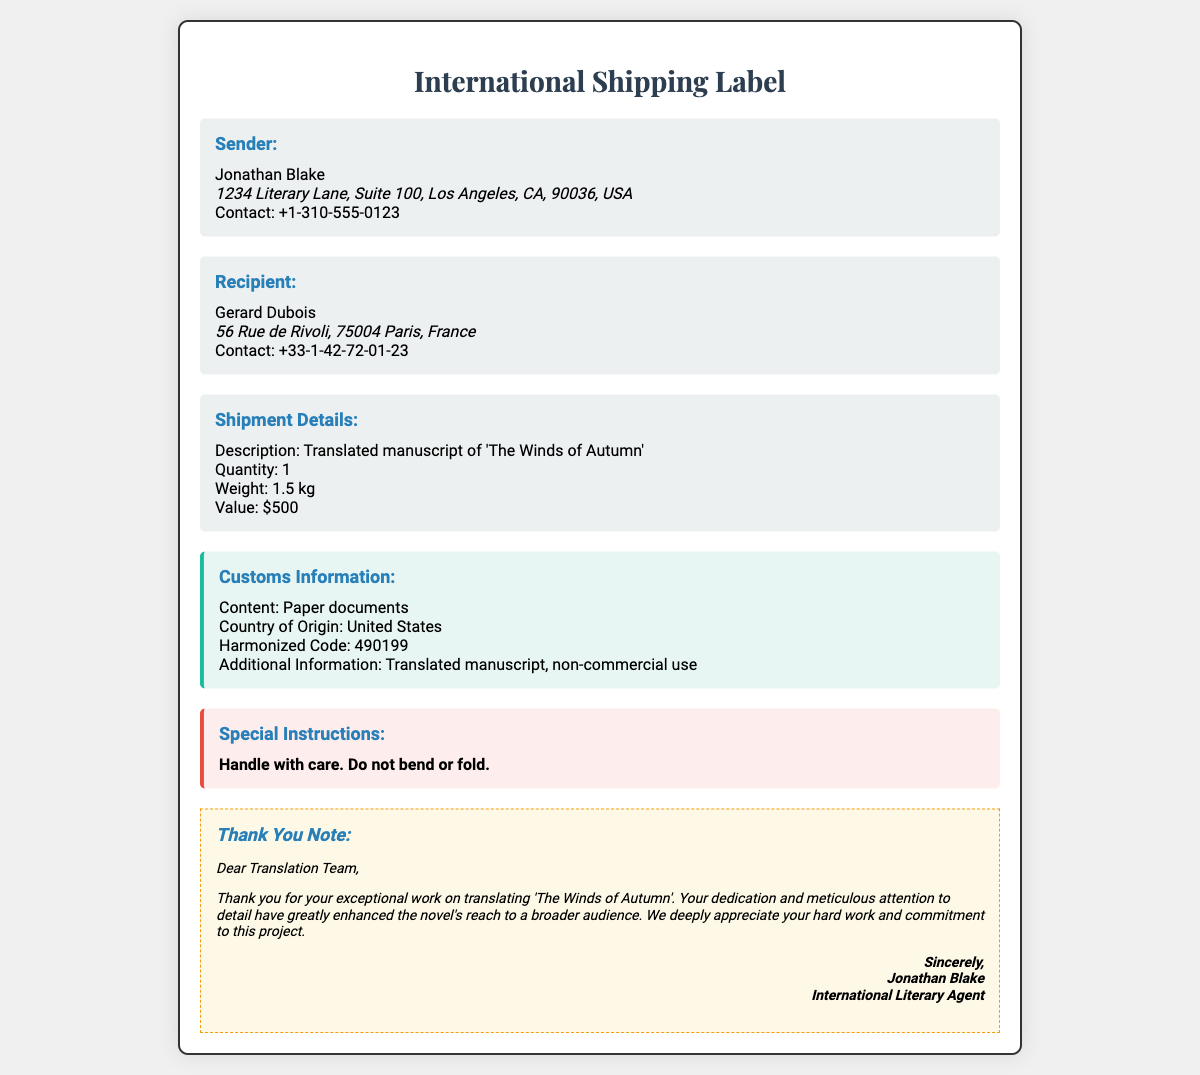What is the sender's name? The sender's name is listed at the top of the sender section.
Answer: Jonathan Blake What is the recipient's address? The recipient's address is given in the recipient section.
Answer: 56 Rue de Rivoli, 75004 Paris, France What is the weight of the shipment? The weight is specified under the shipment details.
Answer: 1.5 kg What is the value of the translated manuscript? The value is noted in the shipment details section.
Answer: $500 What is the harmonized code for customs? The harmonized code is provided in the customs information section.
Answer: 490199 What content type is declared for customs? The content type is mentioned in the customs information section.
Answer: Paper documents What special instruction is mentioned for handling the package? The special instruction can be found in the special instructions section.
Answer: Handle with care What is the title of the translated manuscript? The title is mentioned in the shipment details section.
Answer: The Winds of Autumn Who is the intended recipient of the thank you note? The thank you note addresses the team responsible for the translation.
Answer: Translation Team 